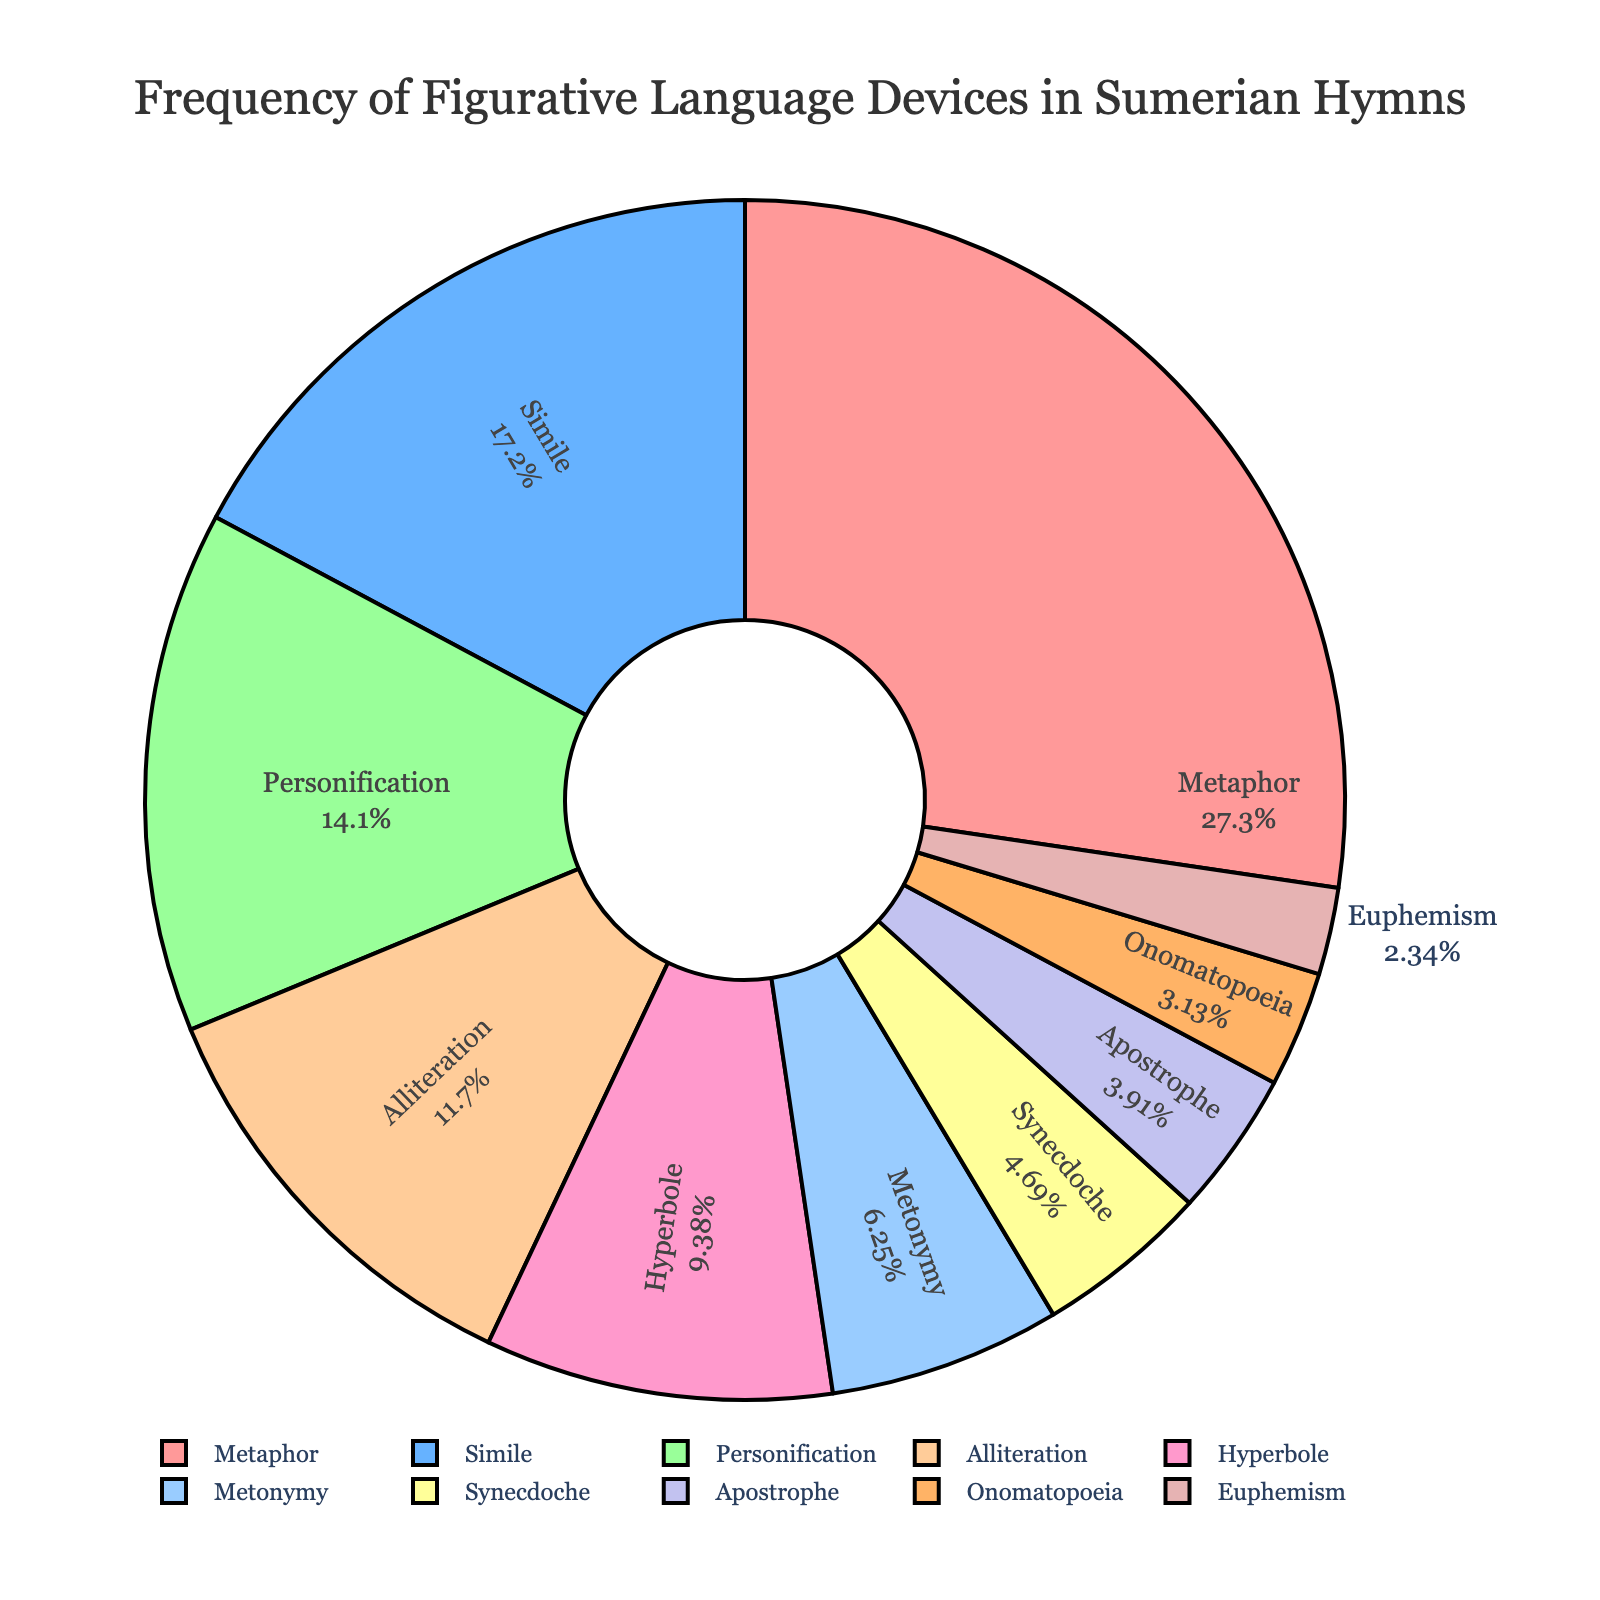What figurative device has the highest frequency in Sumerian hymns? The largest slice in the pie chart corresponds to Metaphor, indicating it has the highest frequency.
Answer: Metaphor What is the combined percentage of Metaphors and Similes used? Metaphors account for 35%, and Similes account for 22%. Adding these percentages gives 35% + 22% = 57%.
Answer: 57% Is Metonymy used more frequently than Synecdoche? By comparing the sizes of the pie slices, Metonymy (8) is larger than Synecdoche (6), indicating Metonymy is used more frequently.
Answer: Yes Which devices together make up at least half of the figurative language occurrences? Adding the percentages: Metaphor (35%) + Simile (22%) gives 57%, which is more than half (50%).
Answer: Metaphor and Simile What visual attributes signify the least used figurative device? The smallest slice of the pie chart is labeled for Euphemism, indicating it is the least used device.
Answer: Euphemism How many more instances of Personification are there compared to Onomatopoeia? Personification has a frequency of 18 and Onomatopoeia has a frequency of 4. The difference is 18 - 4 = 14.
Answer: 14 instances Which devices have a frequency less than 10? By observing the sizes and frequencies, Metonymy (8), Synecdoche (6), Apostrophe (5), Onomatopoeia (4), and Euphemism (3) all have frequencies less than 10.
Answer: Metonymy, Synecdoche, Apostrophe, Onomatopoeia, Euphemism If you sum the frequencies of all devices except Metaphor and Simile, what is the total? Frequencies excluding Metaphor and Simile: 18 (Personification) + 15 (Alliteration) + 12 (Hyperbole) + 8 (Metonymy) + 6 (Synecdoche) + 5 (Apostrophe) + 4 (Onomatopoeia) + 3 (Euphemism) = 71.
Answer: 71 Which color is used to represent Hyperbole? By identifying the colors and corresponding labels in the pie chart, Hyperbole is represented by a light pinkish hue.
Answer: Light pink Can you list the devices in descending order of their frequencies? By referring to the sizes of slices: Metaphor (35), Simile (22), Personification (18), Alliteration (15), Hyperbole (12), Metonymy (8), Synecdoche (6), Apostrophe (5), Onomatopoeia (4), Euphemism (3).
Answer: Metaphor, Simile, Personification, Alliteration, Hyperbole, Metonymy, Synecdoche, Apostrophe, Onomatopoeia, Euphemism 